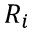Convert formula to latex. <formula><loc_0><loc_0><loc_500><loc_500>R _ { i }</formula> 